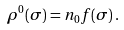Convert formula to latex. <formula><loc_0><loc_0><loc_500><loc_500>\rho ^ { 0 } ( \sigma ) = n _ { 0 } f ( \sigma ) \, .</formula> 